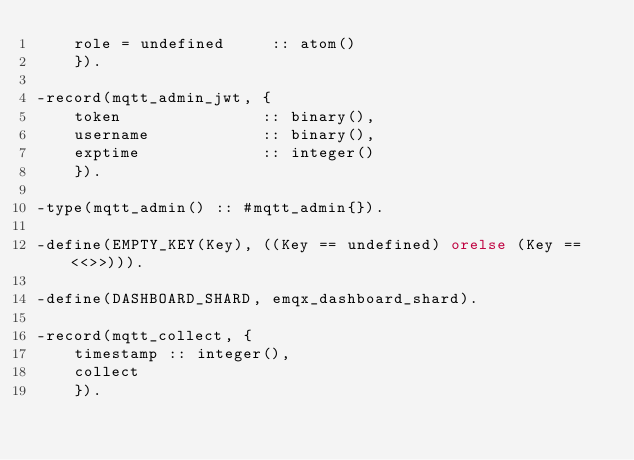Convert code to text. <code><loc_0><loc_0><loc_500><loc_500><_Erlang_>    role = undefined     :: atom()
    }).

-record(mqtt_admin_jwt, {
    token               :: binary(),
    username            :: binary(),
    exptime             :: integer()
    }).

-type(mqtt_admin() :: #mqtt_admin{}).

-define(EMPTY_KEY(Key), ((Key == undefined) orelse (Key == <<>>))).

-define(DASHBOARD_SHARD, emqx_dashboard_shard).

-record(mqtt_collect, {
    timestamp :: integer(),
    collect
    }).
</code> 